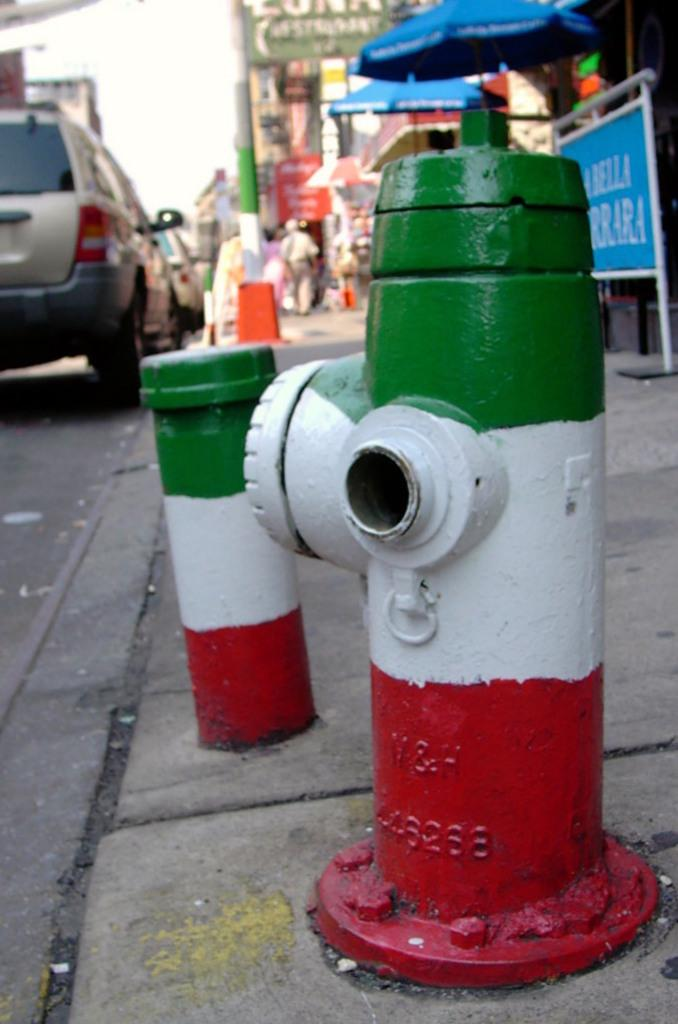How many fire extinguishers can be seen in the image? There are two fire extinguishers in the image. What is visible behind the fire extinguishers? There are vehicles visible behind the fire extinguishers. What type of establishments are on the right side of the image? There are stores on the right side of the image. Can you describe the people in the image? Yes, there are people in the image. What type of behavior does the goose exhibit in the image? There is no goose present in the image, so it is not possible to describe its behavior. 